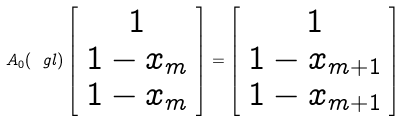Convert formula to latex. <formula><loc_0><loc_0><loc_500><loc_500>A _ { 0 } ( \ g l ) \left [ \begin{array} { c } 1 \\ 1 - x _ { m } \\ 1 - x _ { m } \end{array} \right ] = \left [ \begin{array} { c } 1 \\ 1 - x _ { m + 1 } \\ 1 - x _ { m + 1 } \end{array} \right ]</formula> 